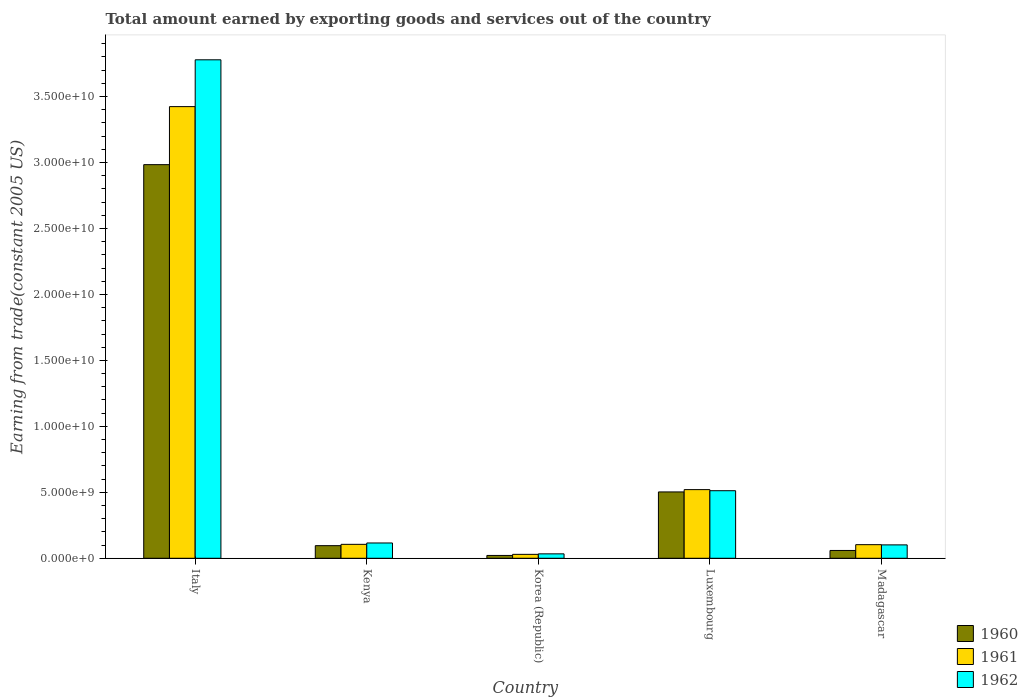How many groups of bars are there?
Your response must be concise. 5. Are the number of bars per tick equal to the number of legend labels?
Your response must be concise. Yes. Are the number of bars on each tick of the X-axis equal?
Your answer should be very brief. Yes. How many bars are there on the 5th tick from the right?
Make the answer very short. 3. What is the total amount earned by exporting goods and services in 1960 in Korea (Republic)?
Offer a very short reply. 2.14e+08. Across all countries, what is the maximum total amount earned by exporting goods and services in 1961?
Give a very brief answer. 3.42e+1. Across all countries, what is the minimum total amount earned by exporting goods and services in 1960?
Keep it short and to the point. 2.14e+08. What is the total total amount earned by exporting goods and services in 1962 in the graph?
Your answer should be very brief. 4.54e+1. What is the difference between the total amount earned by exporting goods and services in 1962 in Italy and that in Korea (Republic)?
Keep it short and to the point. 3.75e+1. What is the difference between the total amount earned by exporting goods and services in 1961 in Luxembourg and the total amount earned by exporting goods and services in 1960 in Madagascar?
Give a very brief answer. 4.61e+09. What is the average total amount earned by exporting goods and services in 1961 per country?
Your answer should be very brief. 8.37e+09. What is the difference between the total amount earned by exporting goods and services of/in 1962 and total amount earned by exporting goods and services of/in 1960 in Madagascar?
Offer a very short reply. 4.24e+08. In how many countries, is the total amount earned by exporting goods and services in 1960 greater than 15000000000 US$?
Your answer should be compact. 1. What is the ratio of the total amount earned by exporting goods and services in 1962 in Italy to that in Kenya?
Your answer should be compact. 32.58. Is the total amount earned by exporting goods and services in 1962 in Korea (Republic) less than that in Luxembourg?
Give a very brief answer. Yes. Is the difference between the total amount earned by exporting goods and services in 1962 in Luxembourg and Madagascar greater than the difference between the total amount earned by exporting goods and services in 1960 in Luxembourg and Madagascar?
Provide a short and direct response. No. What is the difference between the highest and the second highest total amount earned by exporting goods and services in 1960?
Your answer should be very brief. -2.89e+1. What is the difference between the highest and the lowest total amount earned by exporting goods and services in 1962?
Provide a short and direct response. 3.75e+1. In how many countries, is the total amount earned by exporting goods and services in 1960 greater than the average total amount earned by exporting goods and services in 1960 taken over all countries?
Your answer should be compact. 1. Is the sum of the total amount earned by exporting goods and services in 1962 in Italy and Kenya greater than the maximum total amount earned by exporting goods and services in 1960 across all countries?
Provide a short and direct response. Yes. What does the 3rd bar from the left in Madagascar represents?
Your answer should be very brief. 1962. How many bars are there?
Offer a very short reply. 15. What is the difference between two consecutive major ticks on the Y-axis?
Ensure brevity in your answer.  5.00e+09. Does the graph contain any zero values?
Your answer should be very brief. No. Does the graph contain grids?
Make the answer very short. No. Where does the legend appear in the graph?
Make the answer very short. Bottom right. How many legend labels are there?
Your answer should be very brief. 3. How are the legend labels stacked?
Keep it short and to the point. Vertical. What is the title of the graph?
Your response must be concise. Total amount earned by exporting goods and services out of the country. Does "1970" appear as one of the legend labels in the graph?
Make the answer very short. No. What is the label or title of the Y-axis?
Your answer should be compact. Earning from trade(constant 2005 US). What is the Earning from trade(constant 2005 US) of 1960 in Italy?
Your response must be concise. 2.98e+1. What is the Earning from trade(constant 2005 US) of 1961 in Italy?
Your answer should be very brief. 3.42e+1. What is the Earning from trade(constant 2005 US) in 1962 in Italy?
Your answer should be compact. 3.78e+1. What is the Earning from trade(constant 2005 US) of 1960 in Kenya?
Provide a short and direct response. 9.56e+08. What is the Earning from trade(constant 2005 US) in 1961 in Kenya?
Your answer should be very brief. 1.06e+09. What is the Earning from trade(constant 2005 US) of 1962 in Kenya?
Make the answer very short. 1.16e+09. What is the Earning from trade(constant 2005 US) in 1960 in Korea (Republic)?
Offer a terse response. 2.14e+08. What is the Earning from trade(constant 2005 US) in 1961 in Korea (Republic)?
Keep it short and to the point. 2.96e+08. What is the Earning from trade(constant 2005 US) in 1962 in Korea (Republic)?
Offer a terse response. 3.35e+08. What is the Earning from trade(constant 2005 US) in 1960 in Luxembourg?
Keep it short and to the point. 5.03e+09. What is the Earning from trade(constant 2005 US) in 1961 in Luxembourg?
Make the answer very short. 5.20e+09. What is the Earning from trade(constant 2005 US) in 1962 in Luxembourg?
Offer a terse response. 5.12e+09. What is the Earning from trade(constant 2005 US) in 1960 in Madagascar?
Keep it short and to the point. 5.92e+08. What is the Earning from trade(constant 2005 US) in 1961 in Madagascar?
Ensure brevity in your answer.  1.03e+09. What is the Earning from trade(constant 2005 US) of 1962 in Madagascar?
Offer a very short reply. 1.02e+09. Across all countries, what is the maximum Earning from trade(constant 2005 US) of 1960?
Keep it short and to the point. 2.98e+1. Across all countries, what is the maximum Earning from trade(constant 2005 US) of 1961?
Your answer should be compact. 3.42e+1. Across all countries, what is the maximum Earning from trade(constant 2005 US) of 1962?
Your response must be concise. 3.78e+1. Across all countries, what is the minimum Earning from trade(constant 2005 US) of 1960?
Your answer should be very brief. 2.14e+08. Across all countries, what is the minimum Earning from trade(constant 2005 US) in 1961?
Provide a succinct answer. 2.96e+08. Across all countries, what is the minimum Earning from trade(constant 2005 US) in 1962?
Give a very brief answer. 3.35e+08. What is the total Earning from trade(constant 2005 US) in 1960 in the graph?
Provide a succinct answer. 3.66e+1. What is the total Earning from trade(constant 2005 US) in 1961 in the graph?
Your answer should be very brief. 4.18e+1. What is the total Earning from trade(constant 2005 US) in 1962 in the graph?
Offer a terse response. 4.54e+1. What is the difference between the Earning from trade(constant 2005 US) in 1960 in Italy and that in Kenya?
Keep it short and to the point. 2.89e+1. What is the difference between the Earning from trade(constant 2005 US) of 1961 in Italy and that in Kenya?
Provide a short and direct response. 3.32e+1. What is the difference between the Earning from trade(constant 2005 US) of 1962 in Italy and that in Kenya?
Your response must be concise. 3.66e+1. What is the difference between the Earning from trade(constant 2005 US) in 1960 in Italy and that in Korea (Republic)?
Your answer should be very brief. 2.96e+1. What is the difference between the Earning from trade(constant 2005 US) of 1961 in Italy and that in Korea (Republic)?
Make the answer very short. 3.39e+1. What is the difference between the Earning from trade(constant 2005 US) in 1962 in Italy and that in Korea (Republic)?
Provide a short and direct response. 3.75e+1. What is the difference between the Earning from trade(constant 2005 US) in 1960 in Italy and that in Luxembourg?
Give a very brief answer. 2.48e+1. What is the difference between the Earning from trade(constant 2005 US) in 1961 in Italy and that in Luxembourg?
Your response must be concise. 2.90e+1. What is the difference between the Earning from trade(constant 2005 US) of 1962 in Italy and that in Luxembourg?
Provide a short and direct response. 3.27e+1. What is the difference between the Earning from trade(constant 2005 US) in 1960 in Italy and that in Madagascar?
Give a very brief answer. 2.92e+1. What is the difference between the Earning from trade(constant 2005 US) in 1961 in Italy and that in Madagascar?
Give a very brief answer. 3.32e+1. What is the difference between the Earning from trade(constant 2005 US) in 1962 in Italy and that in Madagascar?
Keep it short and to the point. 3.68e+1. What is the difference between the Earning from trade(constant 2005 US) of 1960 in Kenya and that in Korea (Republic)?
Your response must be concise. 7.42e+08. What is the difference between the Earning from trade(constant 2005 US) in 1961 in Kenya and that in Korea (Republic)?
Give a very brief answer. 7.60e+08. What is the difference between the Earning from trade(constant 2005 US) in 1962 in Kenya and that in Korea (Republic)?
Provide a short and direct response. 8.24e+08. What is the difference between the Earning from trade(constant 2005 US) in 1960 in Kenya and that in Luxembourg?
Make the answer very short. -4.07e+09. What is the difference between the Earning from trade(constant 2005 US) of 1961 in Kenya and that in Luxembourg?
Give a very brief answer. -4.15e+09. What is the difference between the Earning from trade(constant 2005 US) of 1962 in Kenya and that in Luxembourg?
Offer a very short reply. -3.96e+09. What is the difference between the Earning from trade(constant 2005 US) of 1960 in Kenya and that in Madagascar?
Provide a short and direct response. 3.64e+08. What is the difference between the Earning from trade(constant 2005 US) in 1961 in Kenya and that in Madagascar?
Your response must be concise. 2.53e+07. What is the difference between the Earning from trade(constant 2005 US) of 1962 in Kenya and that in Madagascar?
Ensure brevity in your answer.  1.44e+08. What is the difference between the Earning from trade(constant 2005 US) in 1960 in Korea (Republic) and that in Luxembourg?
Your response must be concise. -4.81e+09. What is the difference between the Earning from trade(constant 2005 US) of 1961 in Korea (Republic) and that in Luxembourg?
Offer a terse response. -4.91e+09. What is the difference between the Earning from trade(constant 2005 US) of 1962 in Korea (Republic) and that in Luxembourg?
Provide a succinct answer. -4.79e+09. What is the difference between the Earning from trade(constant 2005 US) of 1960 in Korea (Republic) and that in Madagascar?
Your answer should be compact. -3.78e+08. What is the difference between the Earning from trade(constant 2005 US) in 1961 in Korea (Republic) and that in Madagascar?
Make the answer very short. -7.35e+08. What is the difference between the Earning from trade(constant 2005 US) in 1962 in Korea (Republic) and that in Madagascar?
Provide a short and direct response. -6.80e+08. What is the difference between the Earning from trade(constant 2005 US) of 1960 in Luxembourg and that in Madagascar?
Ensure brevity in your answer.  4.44e+09. What is the difference between the Earning from trade(constant 2005 US) of 1961 in Luxembourg and that in Madagascar?
Keep it short and to the point. 4.17e+09. What is the difference between the Earning from trade(constant 2005 US) of 1962 in Luxembourg and that in Madagascar?
Your response must be concise. 4.11e+09. What is the difference between the Earning from trade(constant 2005 US) of 1960 in Italy and the Earning from trade(constant 2005 US) of 1961 in Kenya?
Provide a short and direct response. 2.88e+1. What is the difference between the Earning from trade(constant 2005 US) of 1960 in Italy and the Earning from trade(constant 2005 US) of 1962 in Kenya?
Offer a terse response. 2.87e+1. What is the difference between the Earning from trade(constant 2005 US) in 1961 in Italy and the Earning from trade(constant 2005 US) in 1962 in Kenya?
Make the answer very short. 3.31e+1. What is the difference between the Earning from trade(constant 2005 US) of 1960 in Italy and the Earning from trade(constant 2005 US) of 1961 in Korea (Republic)?
Keep it short and to the point. 2.95e+1. What is the difference between the Earning from trade(constant 2005 US) of 1960 in Italy and the Earning from trade(constant 2005 US) of 1962 in Korea (Republic)?
Your response must be concise. 2.95e+1. What is the difference between the Earning from trade(constant 2005 US) in 1961 in Italy and the Earning from trade(constant 2005 US) in 1962 in Korea (Republic)?
Your answer should be compact. 3.39e+1. What is the difference between the Earning from trade(constant 2005 US) of 1960 in Italy and the Earning from trade(constant 2005 US) of 1961 in Luxembourg?
Your answer should be very brief. 2.46e+1. What is the difference between the Earning from trade(constant 2005 US) in 1960 in Italy and the Earning from trade(constant 2005 US) in 1962 in Luxembourg?
Offer a very short reply. 2.47e+1. What is the difference between the Earning from trade(constant 2005 US) in 1961 in Italy and the Earning from trade(constant 2005 US) in 1962 in Luxembourg?
Provide a succinct answer. 2.91e+1. What is the difference between the Earning from trade(constant 2005 US) in 1960 in Italy and the Earning from trade(constant 2005 US) in 1961 in Madagascar?
Offer a very short reply. 2.88e+1. What is the difference between the Earning from trade(constant 2005 US) in 1960 in Italy and the Earning from trade(constant 2005 US) in 1962 in Madagascar?
Provide a succinct answer. 2.88e+1. What is the difference between the Earning from trade(constant 2005 US) in 1961 in Italy and the Earning from trade(constant 2005 US) in 1962 in Madagascar?
Provide a short and direct response. 3.32e+1. What is the difference between the Earning from trade(constant 2005 US) of 1960 in Kenya and the Earning from trade(constant 2005 US) of 1961 in Korea (Republic)?
Give a very brief answer. 6.59e+08. What is the difference between the Earning from trade(constant 2005 US) of 1960 in Kenya and the Earning from trade(constant 2005 US) of 1962 in Korea (Republic)?
Give a very brief answer. 6.21e+08. What is the difference between the Earning from trade(constant 2005 US) in 1961 in Kenya and the Earning from trade(constant 2005 US) in 1962 in Korea (Republic)?
Keep it short and to the point. 7.21e+08. What is the difference between the Earning from trade(constant 2005 US) of 1960 in Kenya and the Earning from trade(constant 2005 US) of 1961 in Luxembourg?
Your response must be concise. -4.25e+09. What is the difference between the Earning from trade(constant 2005 US) of 1960 in Kenya and the Earning from trade(constant 2005 US) of 1962 in Luxembourg?
Your answer should be very brief. -4.17e+09. What is the difference between the Earning from trade(constant 2005 US) of 1961 in Kenya and the Earning from trade(constant 2005 US) of 1962 in Luxembourg?
Give a very brief answer. -4.06e+09. What is the difference between the Earning from trade(constant 2005 US) in 1960 in Kenya and the Earning from trade(constant 2005 US) in 1961 in Madagascar?
Your response must be concise. -7.55e+07. What is the difference between the Earning from trade(constant 2005 US) of 1960 in Kenya and the Earning from trade(constant 2005 US) of 1962 in Madagascar?
Make the answer very short. -5.94e+07. What is the difference between the Earning from trade(constant 2005 US) in 1961 in Kenya and the Earning from trade(constant 2005 US) in 1962 in Madagascar?
Your answer should be very brief. 4.14e+07. What is the difference between the Earning from trade(constant 2005 US) in 1960 in Korea (Republic) and the Earning from trade(constant 2005 US) in 1961 in Luxembourg?
Give a very brief answer. -4.99e+09. What is the difference between the Earning from trade(constant 2005 US) of 1960 in Korea (Republic) and the Earning from trade(constant 2005 US) of 1962 in Luxembourg?
Give a very brief answer. -4.91e+09. What is the difference between the Earning from trade(constant 2005 US) of 1961 in Korea (Republic) and the Earning from trade(constant 2005 US) of 1962 in Luxembourg?
Ensure brevity in your answer.  -4.82e+09. What is the difference between the Earning from trade(constant 2005 US) in 1960 in Korea (Republic) and the Earning from trade(constant 2005 US) in 1961 in Madagascar?
Your response must be concise. -8.17e+08. What is the difference between the Earning from trade(constant 2005 US) in 1960 in Korea (Republic) and the Earning from trade(constant 2005 US) in 1962 in Madagascar?
Keep it short and to the point. -8.01e+08. What is the difference between the Earning from trade(constant 2005 US) of 1961 in Korea (Republic) and the Earning from trade(constant 2005 US) of 1962 in Madagascar?
Make the answer very short. -7.19e+08. What is the difference between the Earning from trade(constant 2005 US) in 1960 in Luxembourg and the Earning from trade(constant 2005 US) in 1961 in Madagascar?
Your answer should be very brief. 4.00e+09. What is the difference between the Earning from trade(constant 2005 US) of 1960 in Luxembourg and the Earning from trade(constant 2005 US) of 1962 in Madagascar?
Offer a terse response. 4.01e+09. What is the difference between the Earning from trade(constant 2005 US) of 1961 in Luxembourg and the Earning from trade(constant 2005 US) of 1962 in Madagascar?
Provide a short and direct response. 4.19e+09. What is the average Earning from trade(constant 2005 US) of 1960 per country?
Offer a terse response. 7.33e+09. What is the average Earning from trade(constant 2005 US) in 1961 per country?
Keep it short and to the point. 8.37e+09. What is the average Earning from trade(constant 2005 US) in 1962 per country?
Make the answer very short. 9.08e+09. What is the difference between the Earning from trade(constant 2005 US) of 1960 and Earning from trade(constant 2005 US) of 1961 in Italy?
Offer a terse response. -4.40e+09. What is the difference between the Earning from trade(constant 2005 US) of 1960 and Earning from trade(constant 2005 US) of 1962 in Italy?
Offer a terse response. -7.95e+09. What is the difference between the Earning from trade(constant 2005 US) in 1961 and Earning from trade(constant 2005 US) in 1962 in Italy?
Offer a very short reply. -3.55e+09. What is the difference between the Earning from trade(constant 2005 US) in 1960 and Earning from trade(constant 2005 US) in 1961 in Kenya?
Offer a terse response. -1.01e+08. What is the difference between the Earning from trade(constant 2005 US) of 1960 and Earning from trade(constant 2005 US) of 1962 in Kenya?
Offer a terse response. -2.04e+08. What is the difference between the Earning from trade(constant 2005 US) in 1961 and Earning from trade(constant 2005 US) in 1962 in Kenya?
Offer a very short reply. -1.03e+08. What is the difference between the Earning from trade(constant 2005 US) in 1960 and Earning from trade(constant 2005 US) in 1961 in Korea (Republic)?
Ensure brevity in your answer.  -8.24e+07. What is the difference between the Earning from trade(constant 2005 US) in 1960 and Earning from trade(constant 2005 US) in 1962 in Korea (Republic)?
Ensure brevity in your answer.  -1.21e+08. What is the difference between the Earning from trade(constant 2005 US) of 1961 and Earning from trade(constant 2005 US) of 1962 in Korea (Republic)?
Your response must be concise. -3.87e+07. What is the difference between the Earning from trade(constant 2005 US) of 1960 and Earning from trade(constant 2005 US) of 1961 in Luxembourg?
Provide a short and direct response. -1.75e+08. What is the difference between the Earning from trade(constant 2005 US) in 1960 and Earning from trade(constant 2005 US) in 1962 in Luxembourg?
Your response must be concise. -9.22e+07. What is the difference between the Earning from trade(constant 2005 US) in 1961 and Earning from trade(constant 2005 US) in 1962 in Luxembourg?
Your response must be concise. 8.31e+07. What is the difference between the Earning from trade(constant 2005 US) in 1960 and Earning from trade(constant 2005 US) in 1961 in Madagascar?
Give a very brief answer. -4.40e+08. What is the difference between the Earning from trade(constant 2005 US) in 1960 and Earning from trade(constant 2005 US) in 1962 in Madagascar?
Offer a very short reply. -4.24e+08. What is the difference between the Earning from trade(constant 2005 US) of 1961 and Earning from trade(constant 2005 US) of 1962 in Madagascar?
Give a very brief answer. 1.61e+07. What is the ratio of the Earning from trade(constant 2005 US) of 1960 in Italy to that in Kenya?
Provide a short and direct response. 31.22. What is the ratio of the Earning from trade(constant 2005 US) of 1961 in Italy to that in Kenya?
Ensure brevity in your answer.  32.41. What is the ratio of the Earning from trade(constant 2005 US) of 1962 in Italy to that in Kenya?
Offer a very short reply. 32.58. What is the ratio of the Earning from trade(constant 2005 US) of 1960 in Italy to that in Korea (Republic)?
Keep it short and to the point. 139.36. What is the ratio of the Earning from trade(constant 2005 US) of 1961 in Italy to that in Korea (Republic)?
Give a very brief answer. 115.48. What is the ratio of the Earning from trade(constant 2005 US) of 1962 in Italy to that in Korea (Republic)?
Your answer should be very brief. 112.72. What is the ratio of the Earning from trade(constant 2005 US) in 1960 in Italy to that in Luxembourg?
Give a very brief answer. 5.93. What is the ratio of the Earning from trade(constant 2005 US) in 1961 in Italy to that in Luxembourg?
Your answer should be compact. 6.58. What is the ratio of the Earning from trade(constant 2005 US) in 1962 in Italy to that in Luxembourg?
Ensure brevity in your answer.  7.38. What is the ratio of the Earning from trade(constant 2005 US) in 1960 in Italy to that in Madagascar?
Keep it short and to the point. 50.43. What is the ratio of the Earning from trade(constant 2005 US) in 1961 in Italy to that in Madagascar?
Keep it short and to the point. 33.2. What is the ratio of the Earning from trade(constant 2005 US) in 1962 in Italy to that in Madagascar?
Your response must be concise. 37.22. What is the ratio of the Earning from trade(constant 2005 US) in 1960 in Kenya to that in Korea (Republic)?
Your response must be concise. 4.46. What is the ratio of the Earning from trade(constant 2005 US) of 1961 in Kenya to that in Korea (Republic)?
Provide a succinct answer. 3.56. What is the ratio of the Earning from trade(constant 2005 US) in 1962 in Kenya to that in Korea (Republic)?
Make the answer very short. 3.46. What is the ratio of the Earning from trade(constant 2005 US) in 1960 in Kenya to that in Luxembourg?
Your answer should be very brief. 0.19. What is the ratio of the Earning from trade(constant 2005 US) in 1961 in Kenya to that in Luxembourg?
Make the answer very short. 0.2. What is the ratio of the Earning from trade(constant 2005 US) of 1962 in Kenya to that in Luxembourg?
Provide a succinct answer. 0.23. What is the ratio of the Earning from trade(constant 2005 US) in 1960 in Kenya to that in Madagascar?
Offer a very short reply. 1.62. What is the ratio of the Earning from trade(constant 2005 US) of 1961 in Kenya to that in Madagascar?
Your answer should be very brief. 1.02. What is the ratio of the Earning from trade(constant 2005 US) in 1962 in Kenya to that in Madagascar?
Offer a terse response. 1.14. What is the ratio of the Earning from trade(constant 2005 US) of 1960 in Korea (Republic) to that in Luxembourg?
Make the answer very short. 0.04. What is the ratio of the Earning from trade(constant 2005 US) in 1961 in Korea (Republic) to that in Luxembourg?
Your response must be concise. 0.06. What is the ratio of the Earning from trade(constant 2005 US) in 1962 in Korea (Republic) to that in Luxembourg?
Your answer should be compact. 0.07. What is the ratio of the Earning from trade(constant 2005 US) in 1960 in Korea (Republic) to that in Madagascar?
Offer a terse response. 0.36. What is the ratio of the Earning from trade(constant 2005 US) of 1961 in Korea (Republic) to that in Madagascar?
Your answer should be compact. 0.29. What is the ratio of the Earning from trade(constant 2005 US) of 1962 in Korea (Republic) to that in Madagascar?
Make the answer very short. 0.33. What is the ratio of the Earning from trade(constant 2005 US) of 1960 in Luxembourg to that in Madagascar?
Make the answer very short. 8.5. What is the ratio of the Earning from trade(constant 2005 US) of 1961 in Luxembourg to that in Madagascar?
Offer a very short reply. 5.05. What is the ratio of the Earning from trade(constant 2005 US) of 1962 in Luxembourg to that in Madagascar?
Keep it short and to the point. 5.04. What is the difference between the highest and the second highest Earning from trade(constant 2005 US) of 1960?
Your response must be concise. 2.48e+1. What is the difference between the highest and the second highest Earning from trade(constant 2005 US) of 1961?
Offer a terse response. 2.90e+1. What is the difference between the highest and the second highest Earning from trade(constant 2005 US) of 1962?
Your response must be concise. 3.27e+1. What is the difference between the highest and the lowest Earning from trade(constant 2005 US) of 1960?
Provide a short and direct response. 2.96e+1. What is the difference between the highest and the lowest Earning from trade(constant 2005 US) in 1961?
Provide a succinct answer. 3.39e+1. What is the difference between the highest and the lowest Earning from trade(constant 2005 US) in 1962?
Provide a short and direct response. 3.75e+1. 